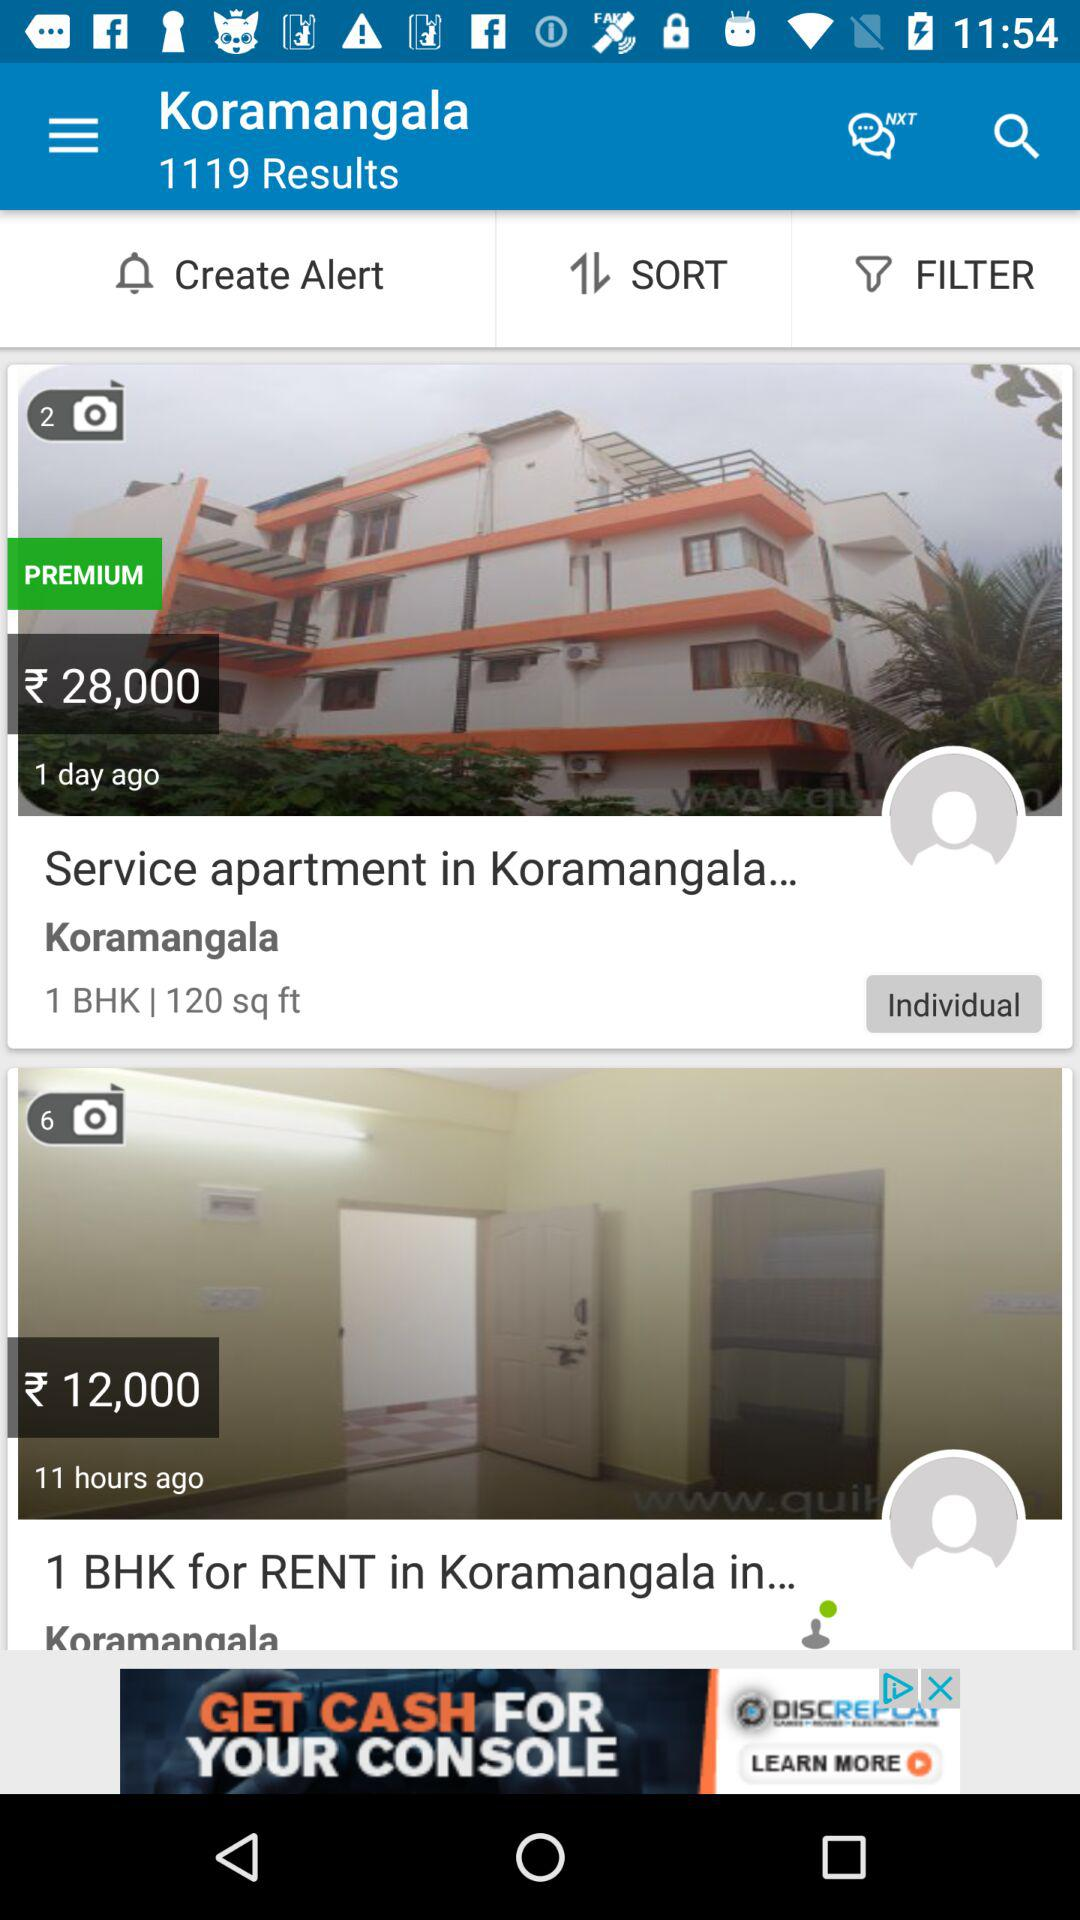What is the size of the service apartment in Koramangala? The size of the service apartment in Koramangala is 120 sq ft. 